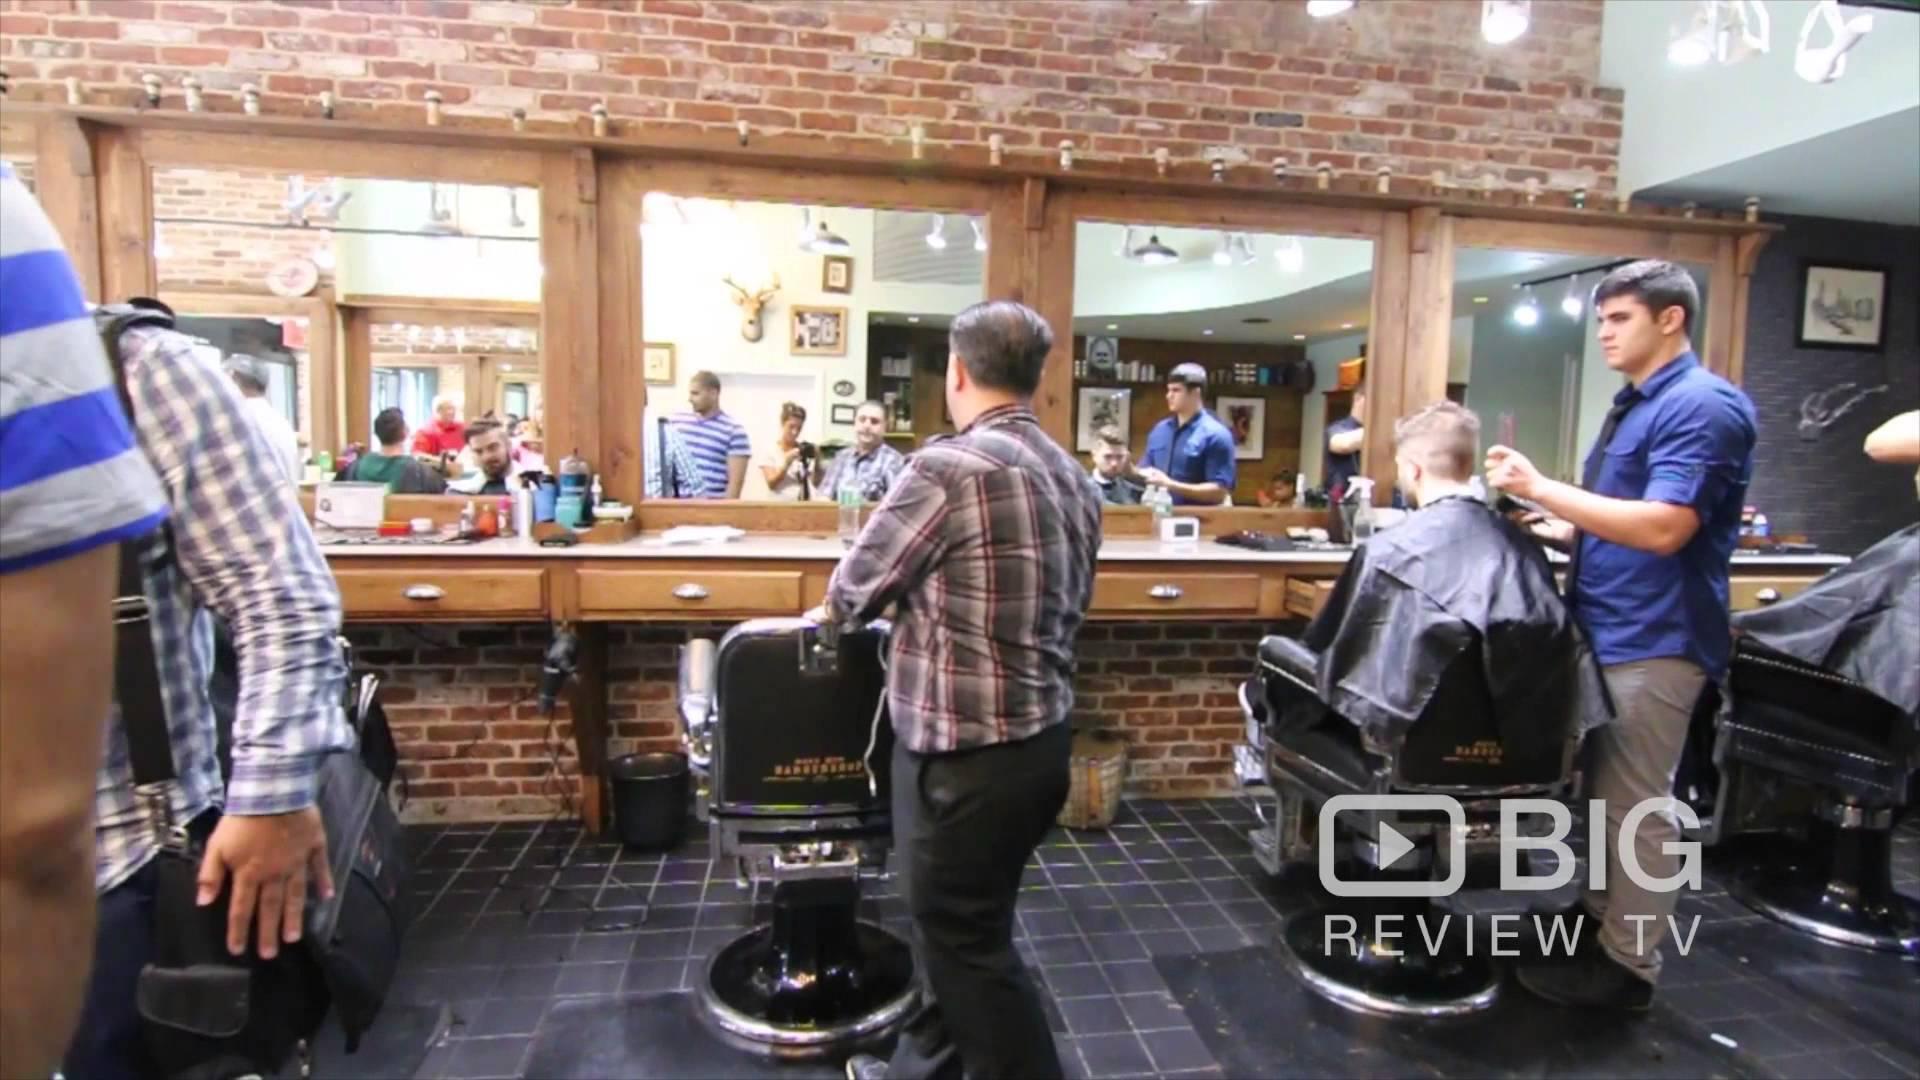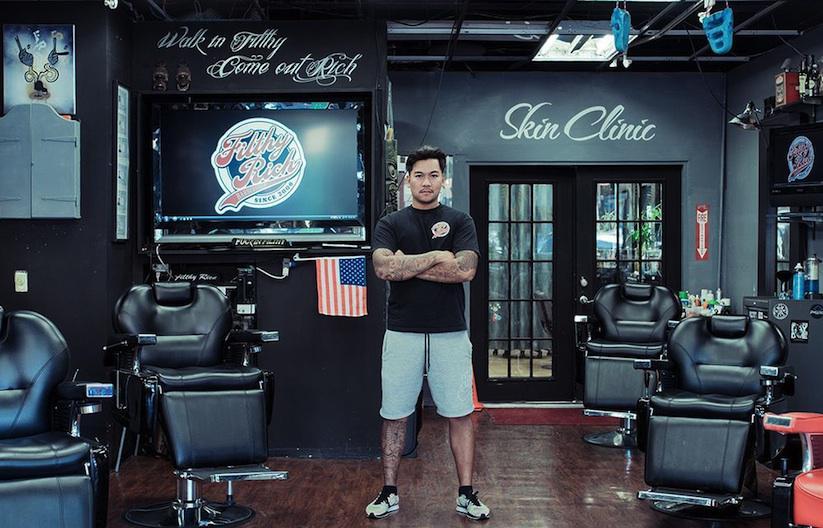The first image is the image on the left, the second image is the image on the right. Considering the images on both sides, is "In at least one image there is a single man posing in the middle of a barber shop." valid? Answer yes or no. Yes. The first image is the image on the left, the second image is the image on the right. For the images displayed, is the sentence "An image includes a row of empty rightward-facing black barber chairs under a row of lights." factually correct? Answer yes or no. No. 